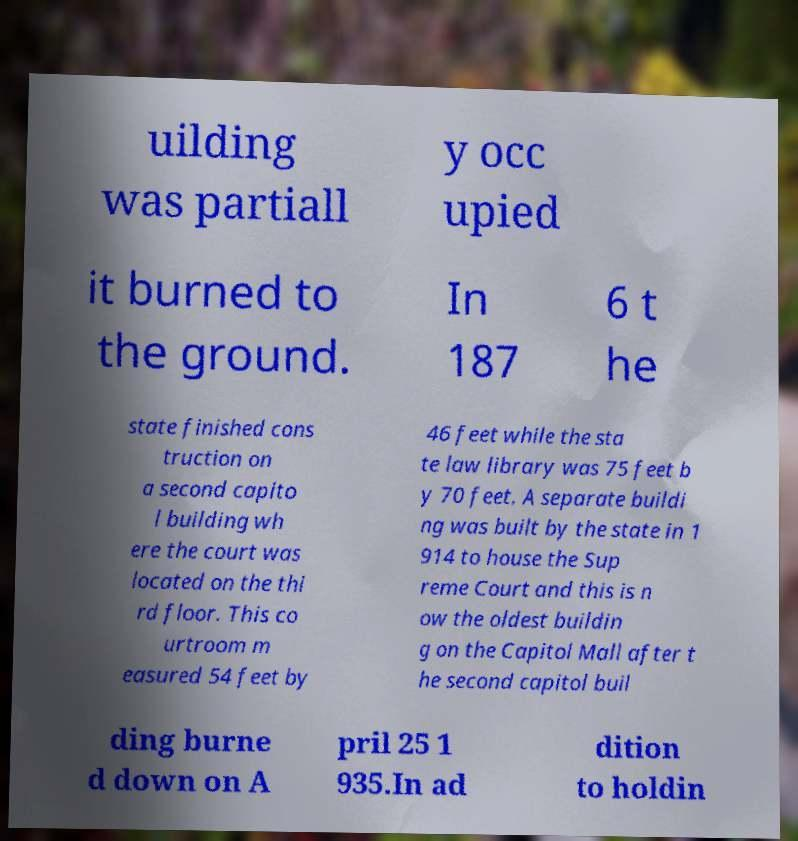Can you accurately transcribe the text from the provided image for me? uilding was partiall y occ upied it burned to the ground. In 187 6 t he state finished cons truction on a second capito l building wh ere the court was located on the thi rd floor. This co urtroom m easured 54 feet by 46 feet while the sta te law library was 75 feet b y 70 feet. A separate buildi ng was built by the state in 1 914 to house the Sup reme Court and this is n ow the oldest buildin g on the Capitol Mall after t he second capitol buil ding burne d down on A pril 25 1 935.In ad dition to holdin 